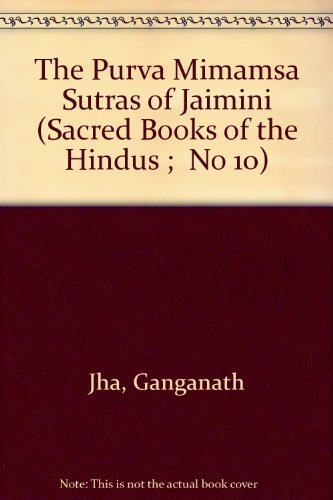Is this book related to Crafts, Hobbies & Home? No, this book is not associated with the Crafts, Hobbies & Home genre. It is a scholarly treatise on Mimamsa, one of the six classical schools of Hindu philosophy. 